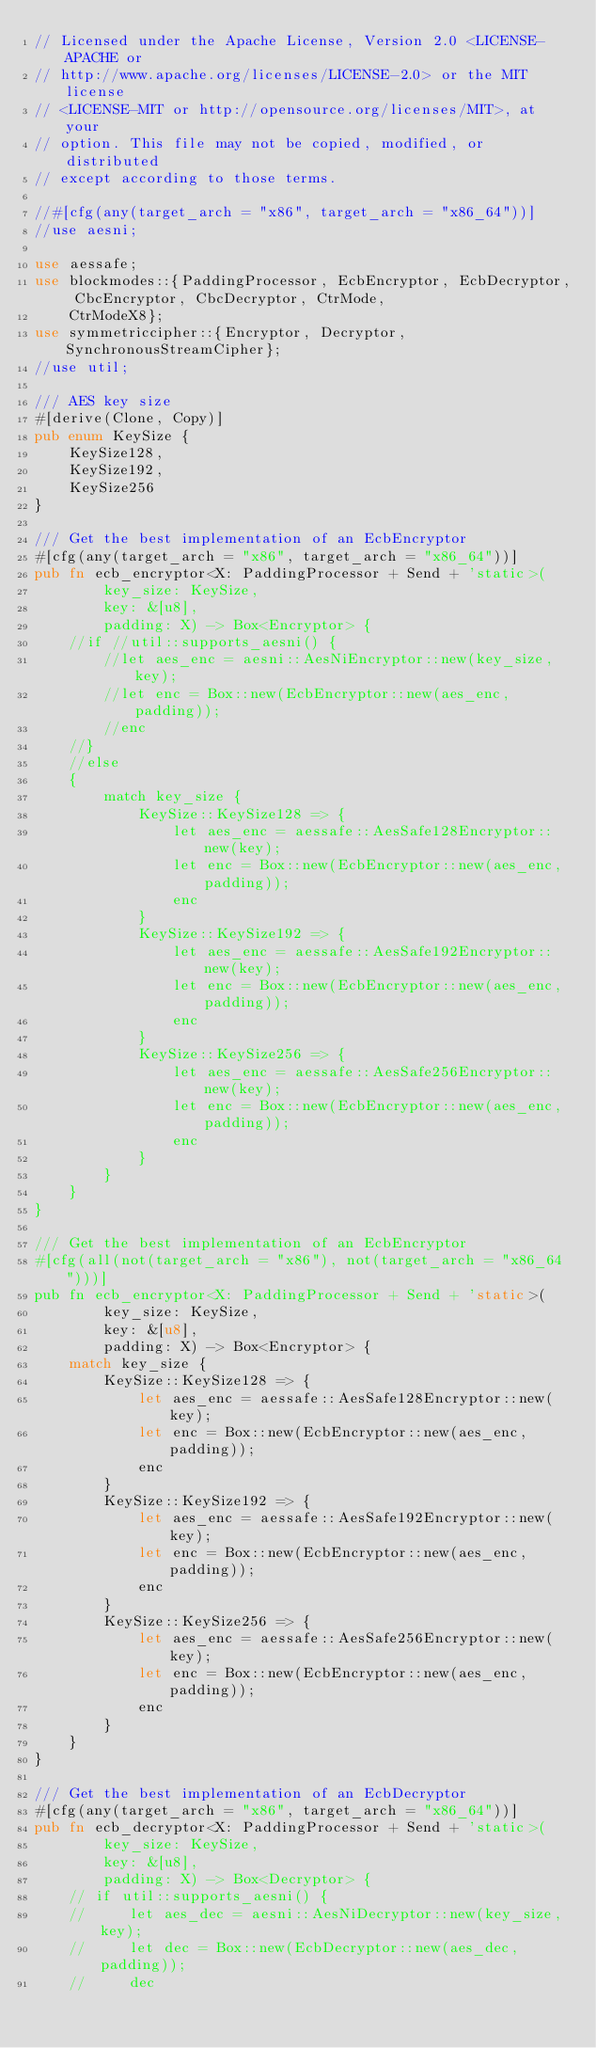Convert code to text. <code><loc_0><loc_0><loc_500><loc_500><_Rust_>// Licensed under the Apache License, Version 2.0 <LICENSE-APACHE or
// http://www.apache.org/licenses/LICENSE-2.0> or the MIT license
// <LICENSE-MIT or http://opensource.org/licenses/MIT>, at your
// option. This file may not be copied, modified, or distributed
// except according to those terms.

//#[cfg(any(target_arch = "x86", target_arch = "x86_64"))]
//use aesni;

use aessafe;
use blockmodes::{PaddingProcessor, EcbEncryptor, EcbDecryptor, CbcEncryptor, CbcDecryptor, CtrMode,
    CtrModeX8};
use symmetriccipher::{Encryptor, Decryptor, SynchronousStreamCipher};
//use util;

/// AES key size
#[derive(Clone, Copy)]
pub enum KeySize {
    KeySize128,
    KeySize192,
    KeySize256
}

/// Get the best implementation of an EcbEncryptor
#[cfg(any(target_arch = "x86", target_arch = "x86_64"))]
pub fn ecb_encryptor<X: PaddingProcessor + Send + 'static>(
        key_size: KeySize,
        key: &[u8],
        padding: X) -> Box<Encryptor> {
    //if //util::supports_aesni() {
        //let aes_enc = aesni::AesNiEncryptor::new(key_size, key);
        //let enc = Box::new(EcbEncryptor::new(aes_enc, padding));
        //enc
    //} 
    //else 
    {
        match key_size {
            KeySize::KeySize128 => {
                let aes_enc = aessafe::AesSafe128Encryptor::new(key);
                let enc = Box::new(EcbEncryptor::new(aes_enc, padding));
                enc
            }
            KeySize::KeySize192 => {
                let aes_enc = aessafe::AesSafe192Encryptor::new(key);
                let enc = Box::new(EcbEncryptor::new(aes_enc, padding));
                enc
            }
            KeySize::KeySize256 => {
                let aes_enc = aessafe::AesSafe256Encryptor::new(key);
                let enc = Box::new(EcbEncryptor::new(aes_enc, padding));
                enc
            }
        }
    }
}

/// Get the best implementation of an EcbEncryptor
#[cfg(all(not(target_arch = "x86"), not(target_arch = "x86_64")))]
pub fn ecb_encryptor<X: PaddingProcessor + Send + 'static>(
        key_size: KeySize,
        key: &[u8],
        padding: X) -> Box<Encryptor> {
    match key_size {
        KeySize::KeySize128 => {
            let aes_enc = aessafe::AesSafe128Encryptor::new(key);
            let enc = Box::new(EcbEncryptor::new(aes_enc, padding));
            enc
        }
        KeySize::KeySize192 => {
            let aes_enc = aessafe::AesSafe192Encryptor::new(key);
            let enc = Box::new(EcbEncryptor::new(aes_enc, padding));
            enc
        }
        KeySize::KeySize256 => {
            let aes_enc = aessafe::AesSafe256Encryptor::new(key);
            let enc = Box::new(EcbEncryptor::new(aes_enc, padding));
            enc
        }
    }
}

/// Get the best implementation of an EcbDecryptor
#[cfg(any(target_arch = "x86", target_arch = "x86_64"))]
pub fn ecb_decryptor<X: PaddingProcessor + Send + 'static>(
        key_size: KeySize,
        key: &[u8],
        padding: X) -> Box<Decryptor> {
    // if util::supports_aesni() {
    //     let aes_dec = aesni::AesNiDecryptor::new(key_size, key);
    //     let dec = Box::new(EcbDecryptor::new(aes_dec, padding));
    //     dec</code> 